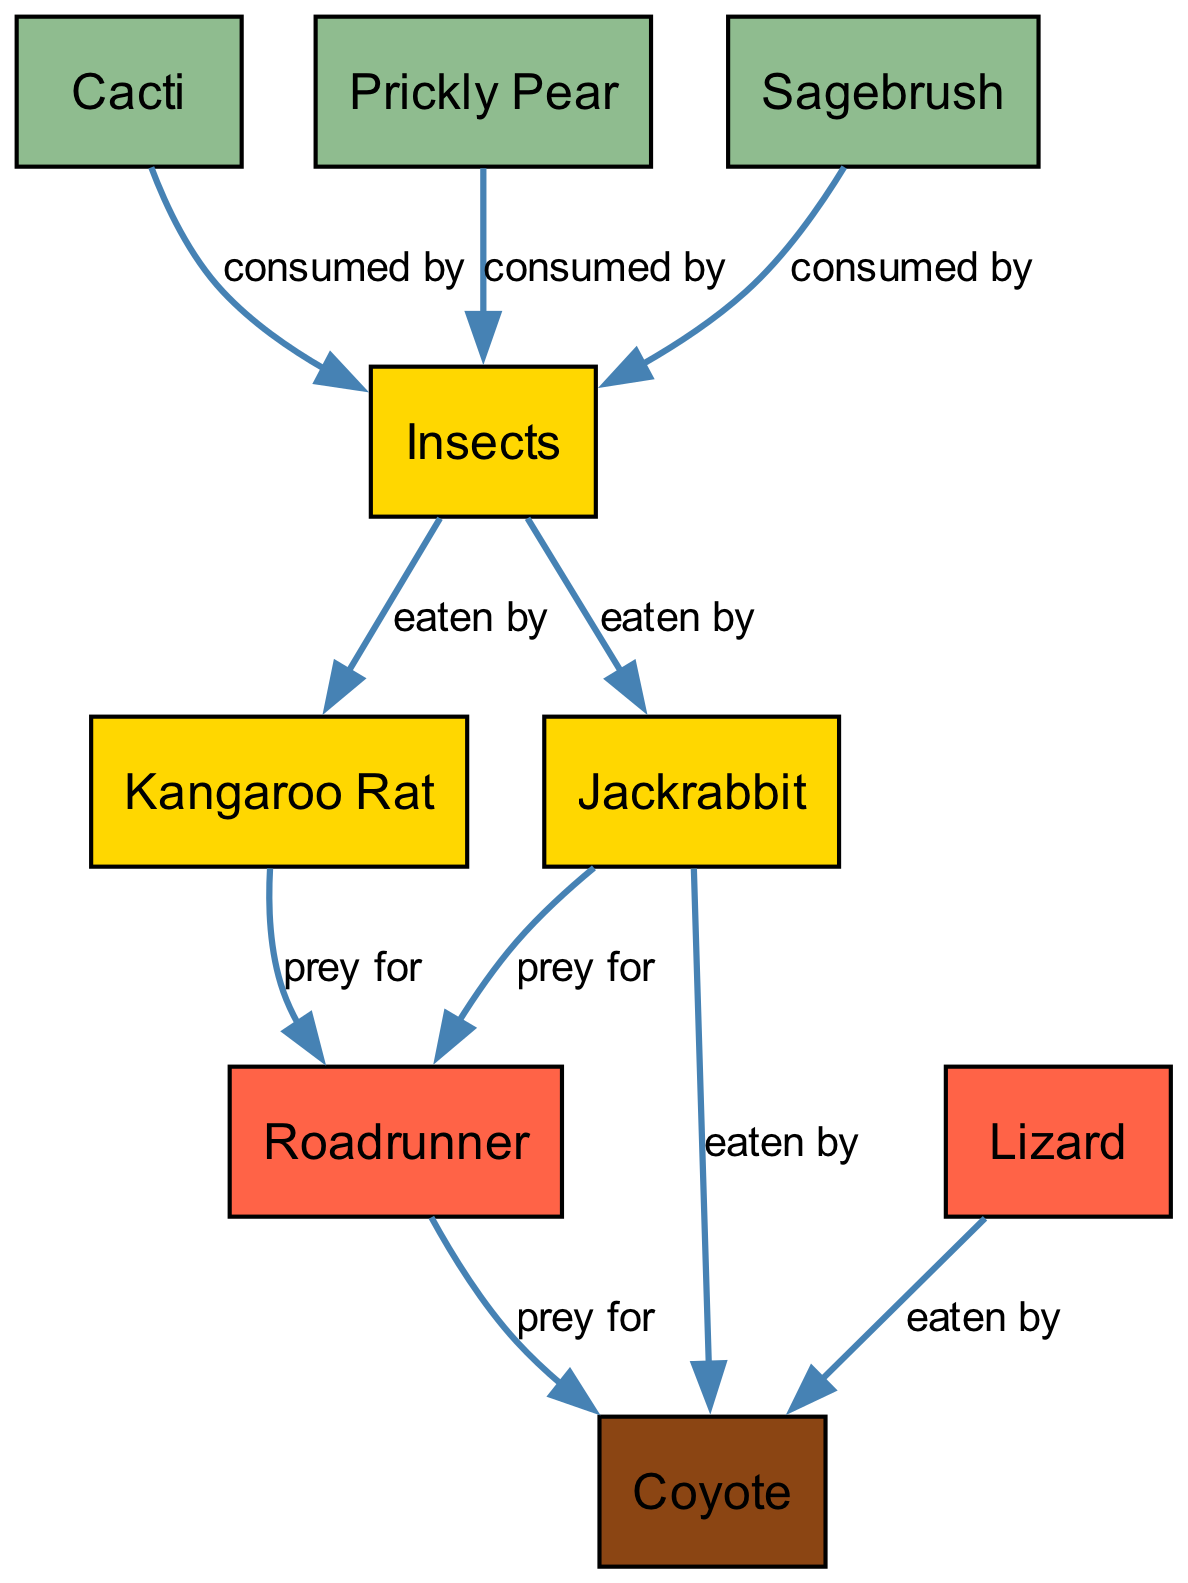What are the producers in the food chain? The producers are the organisms that generate energy through photosynthesis, which includes Cacti, Prickly Pear, and Sagebrush. These can be found at the base of the food chain in the diagram.
Answer: Cacti, Prickly Pear, Sagebrush How many nodes are in the diagram? To find the number of nodes, we simply count the distinct organisms represented in the nodes section of the diagram. There are nine nodes listed.
Answer: 9 Which organism does the Coyote prey on? By following the arrows from Coyote, we can see that it preys on both the Roadrunner and the Jackrabbit. Thus, either of these is a valid answer.
Answer: Roadrunner, Jackrabbit What type of consumer is the Kangaroo Rat? The Kangaroo Rat is listed in the diagram as a primary consumer, which feeds on insects and serves as prey for secondary consumers like the Roadrunner.
Answer: Primary Consumer Which organism is at the top of the food chain? The top of the food chain is represented by the Coyote, which is a tertiary consumer in this ecological hierarchy. We determine this by identifying the organism that has no predators in the diagram.
Answer: Coyote How many edges are connected to the Jackrabbit? To find this, we can count the edges or connections associated with the Jackrabbit. It has two edges: one leading to the Roadrunner and the other leading to the Coyote.
Answer: 2 What do insects consume in the food chain? Insects consume various producers, as indicated by the connections leading into them. Specifically, they can be seen to be eaten by Cacti, Prickly Pear, and Sagebrush as their source of energy.
Answer: Cacti, Prickly Pear, Sagebrush Who is a secondary consumer in this food chain? In the food chain diagram, the secondary consumers are the Lizard and the Roadrunner, as they feed on primary consumers like the Jackrabbit and Kangaroo Rat.
Answer: Lizard, Roadrunner Which two organisms have the most connections? Observing the diagram, we see the Coyote and the Insects have multiple connections, indicating their significant roles in the food chain. The Coyote has three direct connections, while the Insects connect to three producers, so one could argue about their roles.
Answer: Coyote, Insects 